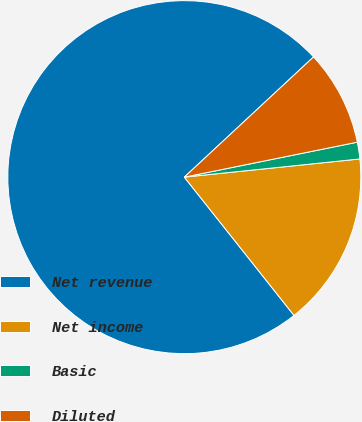Convert chart to OTSL. <chart><loc_0><loc_0><loc_500><loc_500><pie_chart><fcel>Net revenue<fcel>Net income<fcel>Basic<fcel>Diluted<nl><fcel>73.74%<fcel>15.97%<fcel>1.53%<fcel>8.75%<nl></chart> 